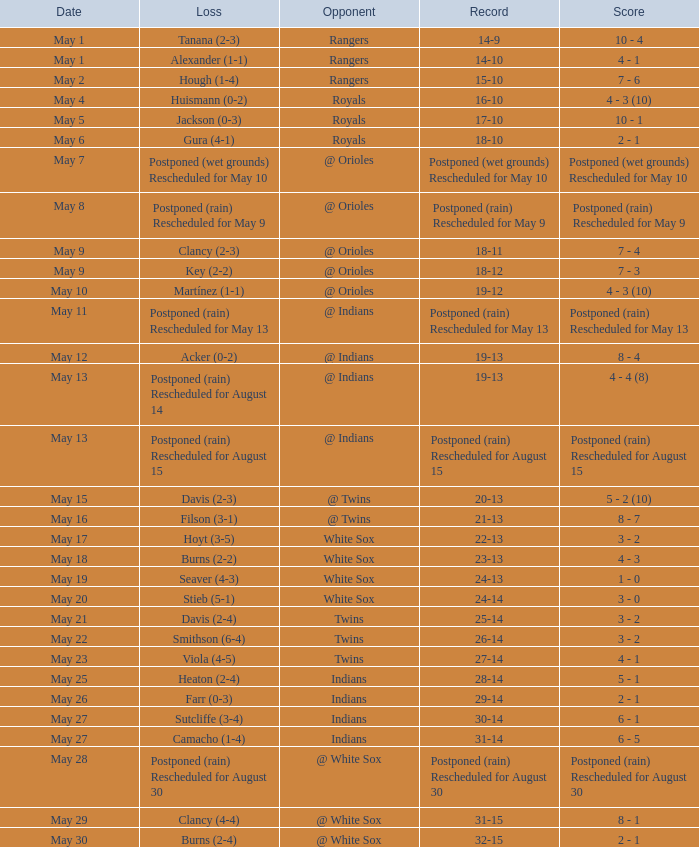What was date of the game when the record was 31-15? May 29. 